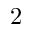Convert formula to latex. <formula><loc_0><loc_0><loc_500><loc_500>2</formula> 